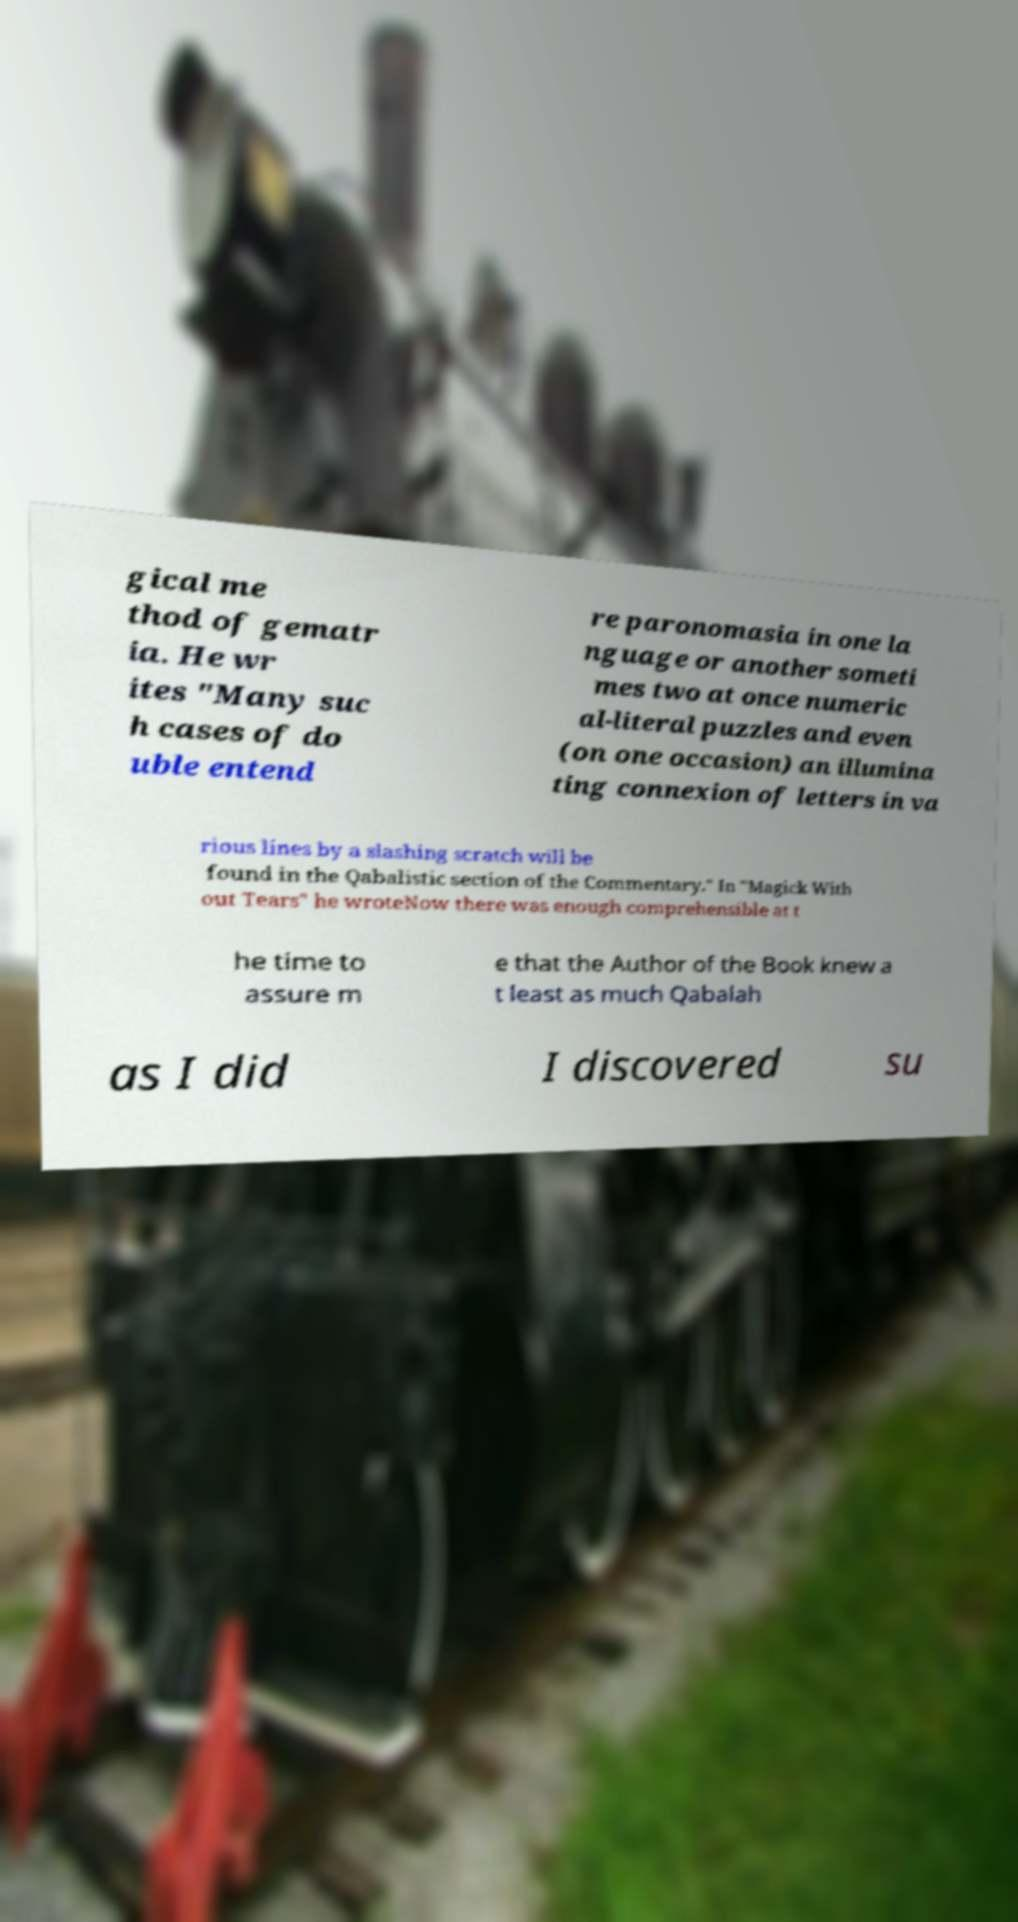Can you accurately transcribe the text from the provided image for me? gical me thod of gematr ia. He wr ites "Many suc h cases of do uble entend re paronomasia in one la nguage or another someti mes two at once numeric al-literal puzzles and even (on one occasion) an illumina ting connexion of letters in va rious lines by a slashing scratch will be found in the Qabalistic section of the Commentary." In "Magick With out Tears" he wroteNow there was enough comprehensible at t he time to assure m e that the Author of the Book knew a t least as much Qabalah as I did I discovered su 